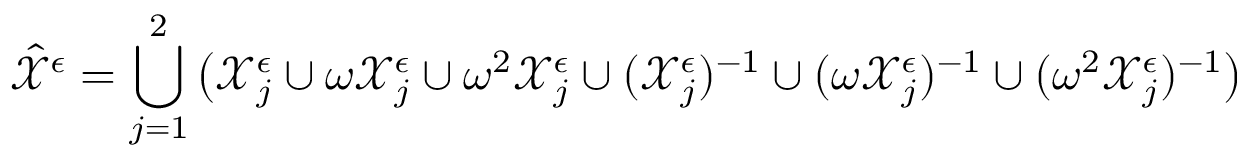Convert formula to latex. <formula><loc_0><loc_0><loc_500><loc_500>\hat { \mathcal { X } } ^ { \epsilon } = \bigcup _ { j = 1 } ^ { 2 } \left ( \mathcal { X } _ { j } ^ { \epsilon } \cup \omega \mathcal { X } _ { j } ^ { \epsilon } \cup \omega ^ { 2 } \mathcal { X } _ { j } ^ { \epsilon } \cup ( \mathcal { X } _ { j } ^ { \epsilon } ) ^ { - 1 } \cup ( \omega \mathcal { X } _ { j } ^ { \epsilon } ) ^ { - 1 } \cup ( \omega ^ { 2 } \mathcal { X } _ { j } ^ { \epsilon } ) ^ { - 1 } \right )</formula> 